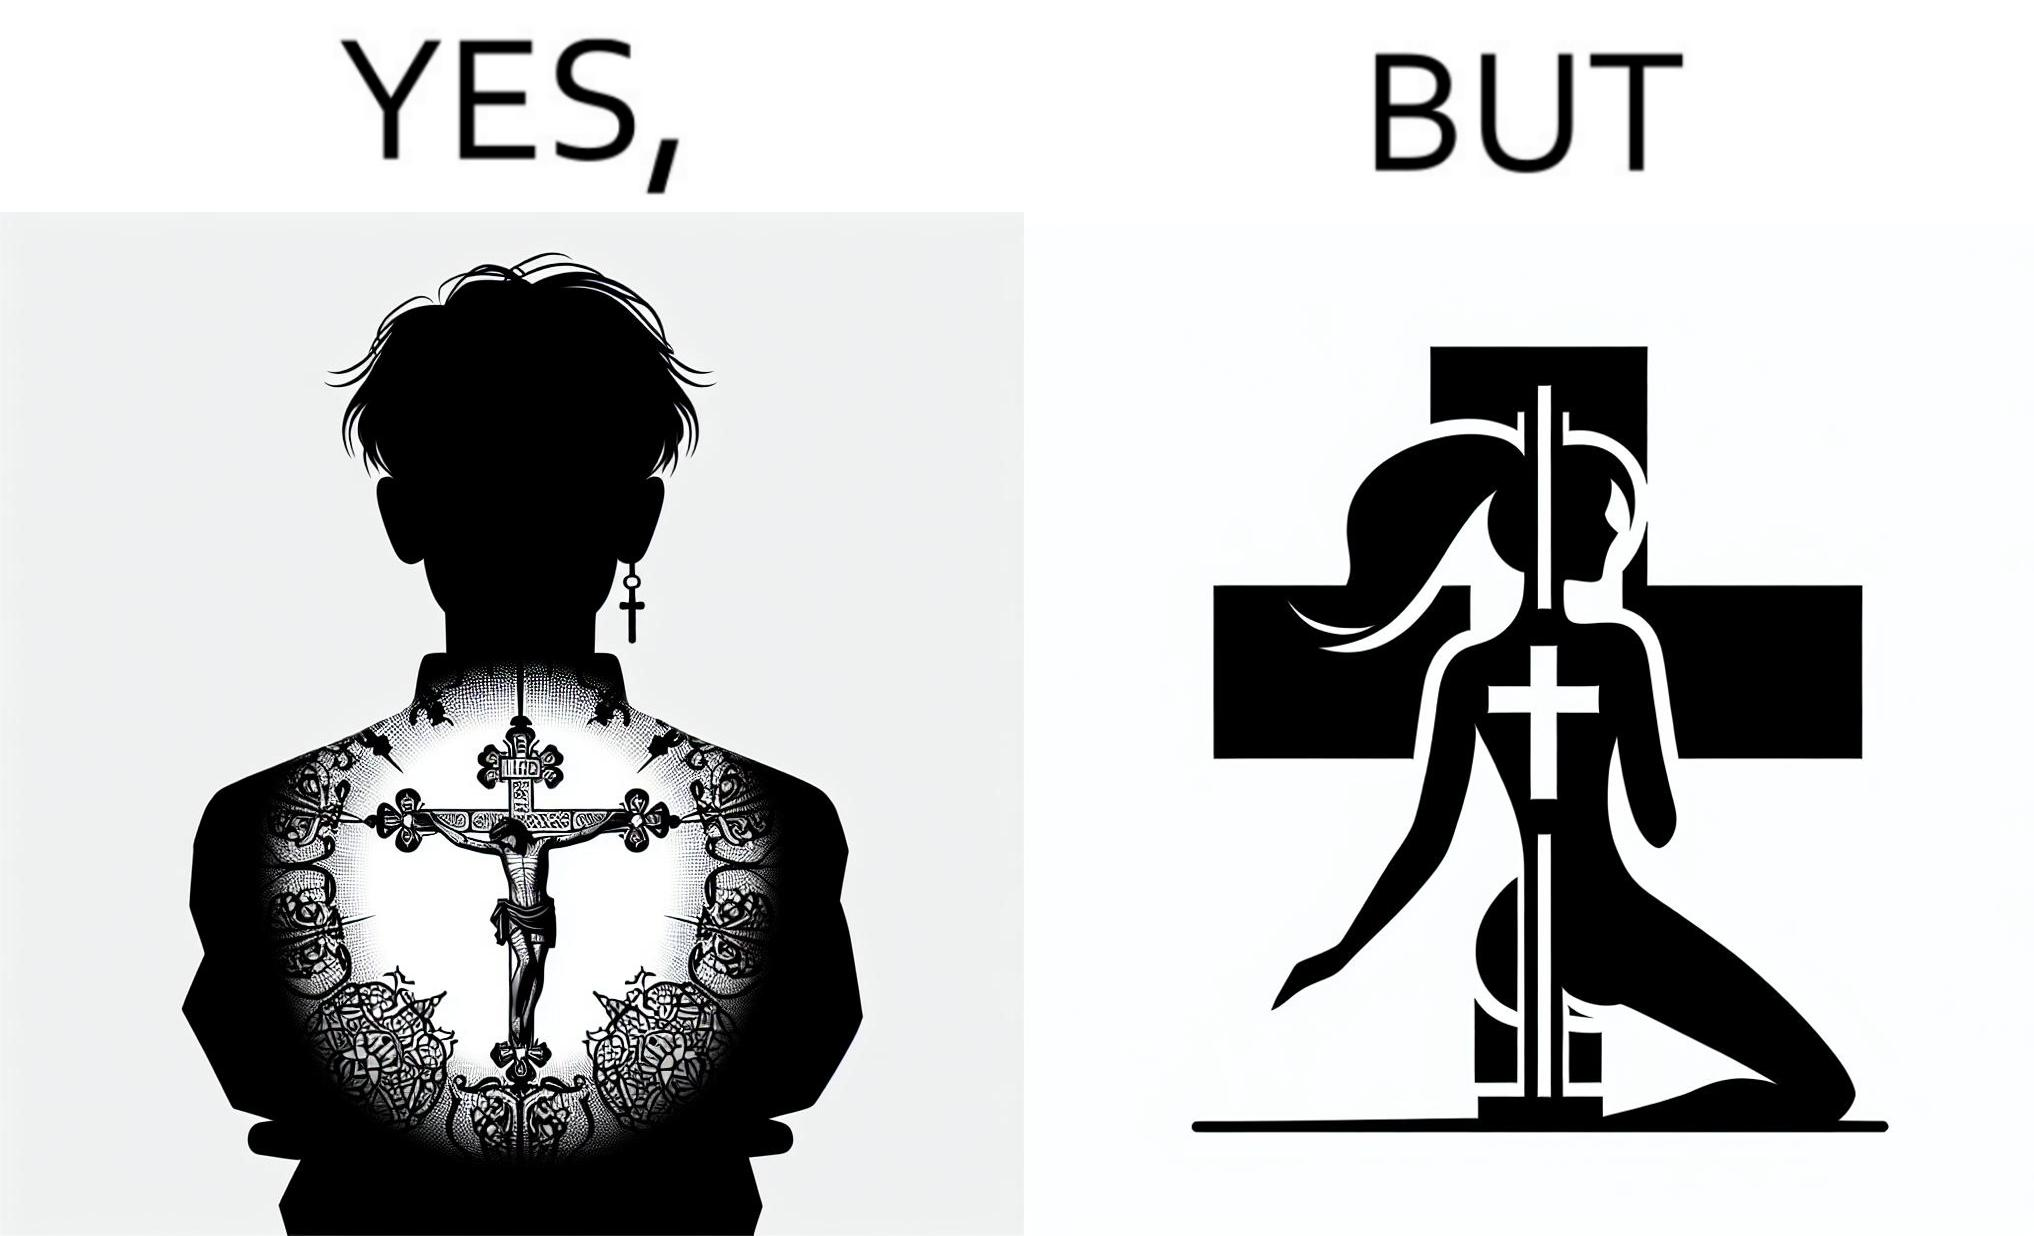Is this a satirical image? Yes, this image is satirical. 